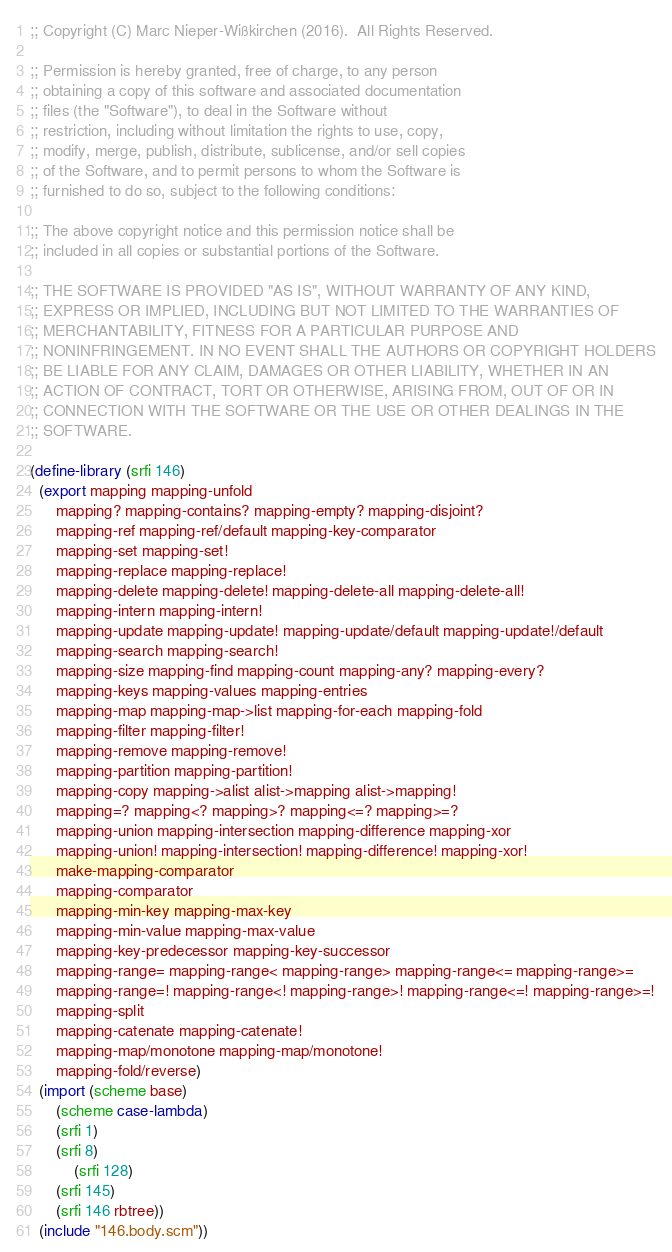Convert code to text. <code><loc_0><loc_0><loc_500><loc_500><_Scheme_>;; Copyright (C) Marc Nieper-Wißkirchen (2016).  All Rights Reserved. 

;; Permission is hereby granted, free of charge, to any person
;; obtaining a copy of this software and associated documentation
;; files (the "Software"), to deal in the Software without
;; restriction, including without limitation the rights to use, copy,
;; modify, merge, publish, distribute, sublicense, and/or sell copies
;; of the Software, and to permit persons to whom the Software is
;; furnished to do so, subject to the following conditions:

;; The above copyright notice and this permission notice shall be
;; included in all copies or substantial portions of the Software.

;; THE SOFTWARE IS PROVIDED "AS IS", WITHOUT WARRANTY OF ANY KIND,
;; EXPRESS OR IMPLIED, INCLUDING BUT NOT LIMITED TO THE WARRANTIES OF
;; MERCHANTABILITY, FITNESS FOR A PARTICULAR PURPOSE AND
;; NONINFRINGEMENT. IN NO EVENT SHALL THE AUTHORS OR COPYRIGHT HOLDERS
;; BE LIABLE FOR ANY CLAIM, DAMAGES OR OTHER LIABILITY, WHETHER IN AN
;; ACTION OF CONTRACT, TORT OR OTHERWISE, ARISING FROM, OUT OF OR IN
;; CONNECTION WITH THE SOFTWARE OR THE USE OR OTHER DEALINGS IN THE
;; SOFTWARE.

(define-library (srfi 146)
  (export mapping mapping-unfold
	  mapping? mapping-contains? mapping-empty? mapping-disjoint?
	  mapping-ref mapping-ref/default mapping-key-comparator
	  mapping-set mapping-set! 
	  mapping-replace mapping-replace!
	  mapping-delete mapping-delete! mapping-delete-all mapping-delete-all!
	  mapping-intern mapping-intern!
	  mapping-update mapping-update! mapping-update/default mapping-update!/default
	  mapping-search mapping-search!
	  mapping-size mapping-find mapping-count mapping-any? mapping-every?
	  mapping-keys mapping-values mapping-entries
	  mapping-map mapping-map->list mapping-for-each mapping-fold
	  mapping-filter mapping-filter!
	  mapping-remove mapping-remove!
	  mapping-partition mapping-partition!
	  mapping-copy mapping->alist alist->mapping alist->mapping!
	  mapping=? mapping<? mapping>? mapping<=? mapping>=?
	  mapping-union mapping-intersection mapping-difference mapping-xor
	  mapping-union! mapping-intersection! mapping-difference! mapping-xor!
	  make-mapping-comparator
	  mapping-comparator
	  mapping-min-key mapping-max-key
	  mapping-min-value mapping-max-value
	  mapping-key-predecessor mapping-key-successor
	  mapping-range= mapping-range< mapping-range> mapping-range<= mapping-range>=
	  mapping-range=! mapping-range<! mapping-range>! mapping-range<=! mapping-range>=!
	  mapping-split
	  mapping-catenate mapping-catenate!
	  mapping-map/monotone mapping-map/monotone!
	  mapping-fold/reverse)
  (import (scheme base)
	  (scheme case-lambda)
	  (srfi 1)
	  (srfi 8)
      	  (srfi 128)
	  (srfi 145)
	  (srfi 146 rbtree))
  (include "146.body.scm"))
</code> 